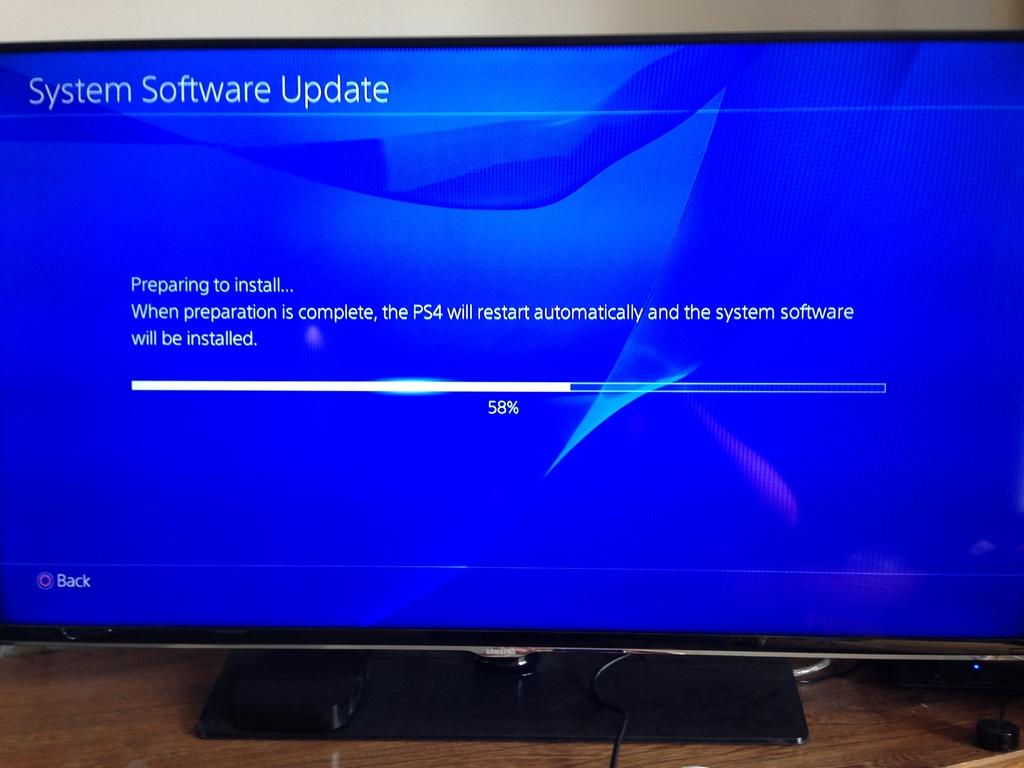Provide a one-sentence caption for the provided image. The computer is 58% of the way through a software update. 